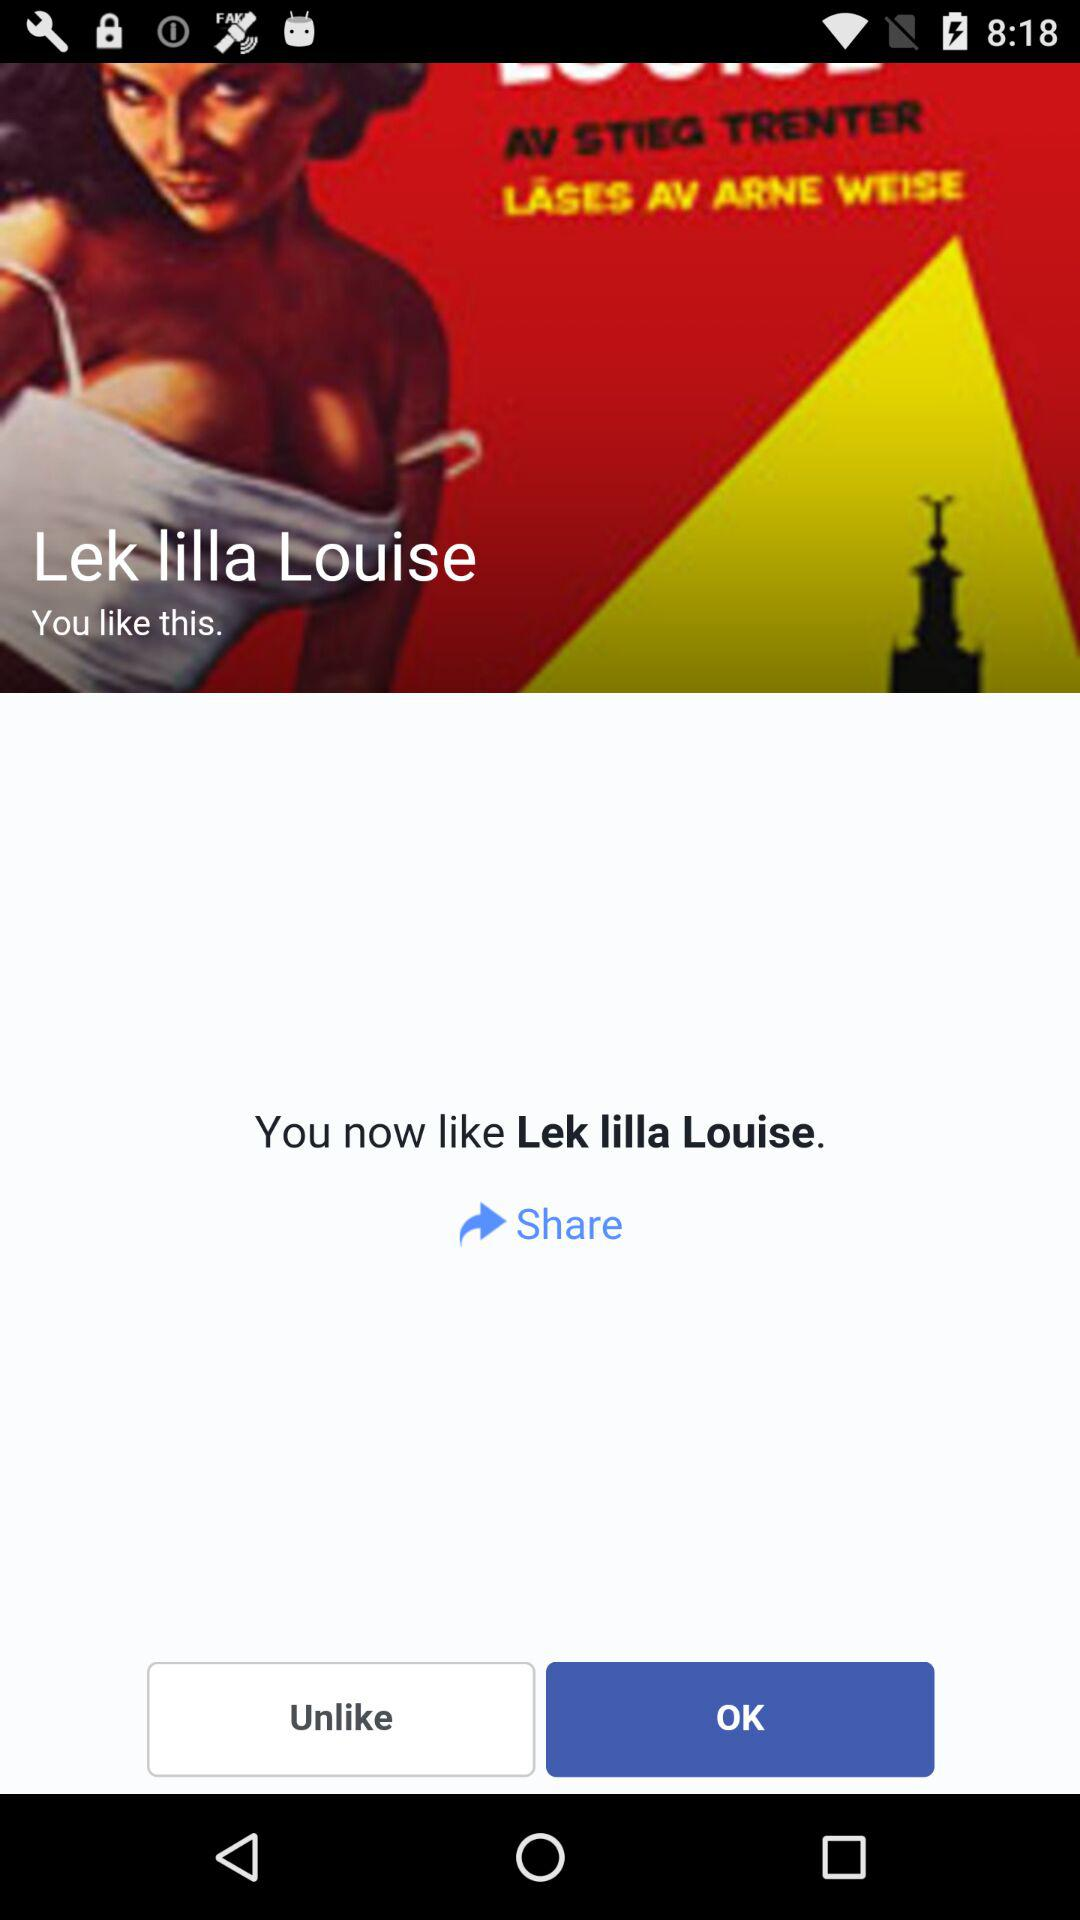What is the user name to share?
When the provided information is insufficient, respond with <no answer>. <no answer> 